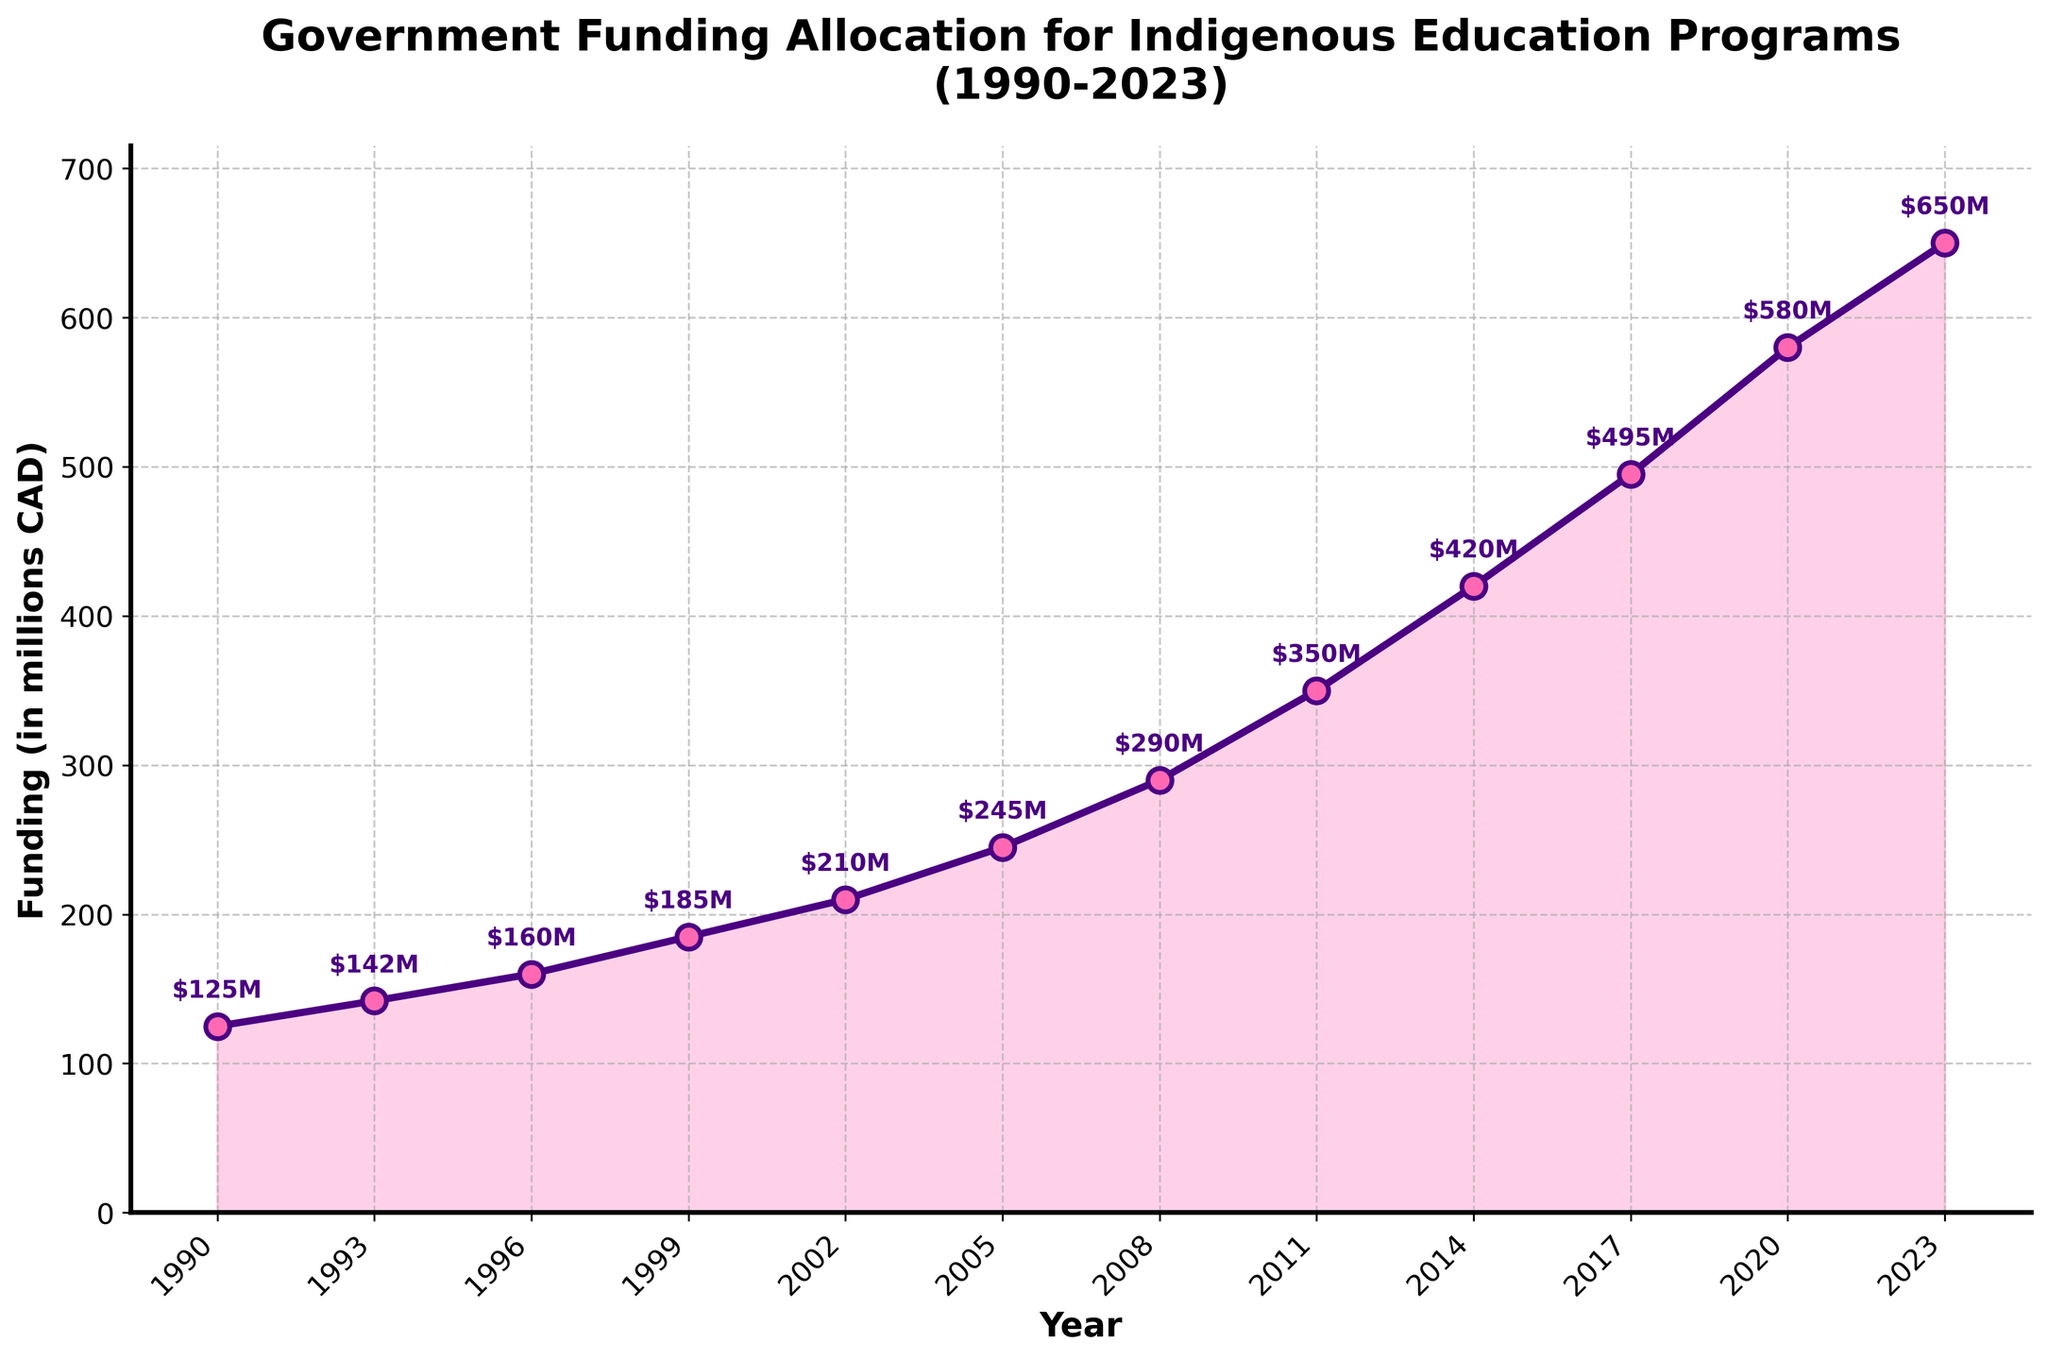What is the funding amount for Indigenous education programs in 1996? Observe the funding value on the y-axis that corresponds to the year 1996 on the x-axis.
Answer: 160 million CAD By how much did the funding increase from 1990 to 2023? Subtract the funding value in 1990 from the funding value in 2023: 650 million CAD - 125 million CAD = 525 million CAD.
Answer: 525 million CAD In which year did the funding reach 350 million CAD? Identify the year on the x-axis where the annotated funding value is 350 million CAD.
Answer: 2011 What is the average funding for the years 2002, 2005, and 2008? Sum the funding values for 2002 (210 million CAD), 2005 (245 million CAD), and 2008 (290 million CAD) and divide by 3: (210 + 245 + 290) / 3 = 745 / 3 = 248.33 million CAD.
Answer: 248.33 million CAD Which period saw the highest increase in funding? Calculate the differences between consecutive years and identify the largest increase by observing the slope: 2020 to 2023 had an increase of 70 million CAD (650 - 580) which is the highest.
Answer: 2020 to 2023 How does the funding in 2014 compare to that in 2002? Check the annotated values for both years and compare them: 420 million CAD in 2014 and 210 million CAD in 2002.
Answer: 2014 was higher What is the median funding value over the three decades? List all funding values in ascending order: 125, 142, 160, 185, 210, 245, 290, 350, 420, 495, 580, 650. The median is the average of the 6th and 7th values: (245 + 290) / 2 = 267.5 million CAD.
Answer: 267.5 million CAD Which color represents the line showing the funding data? Observe the color of the line that plots the funding data over the years.
Answer: Indigo 